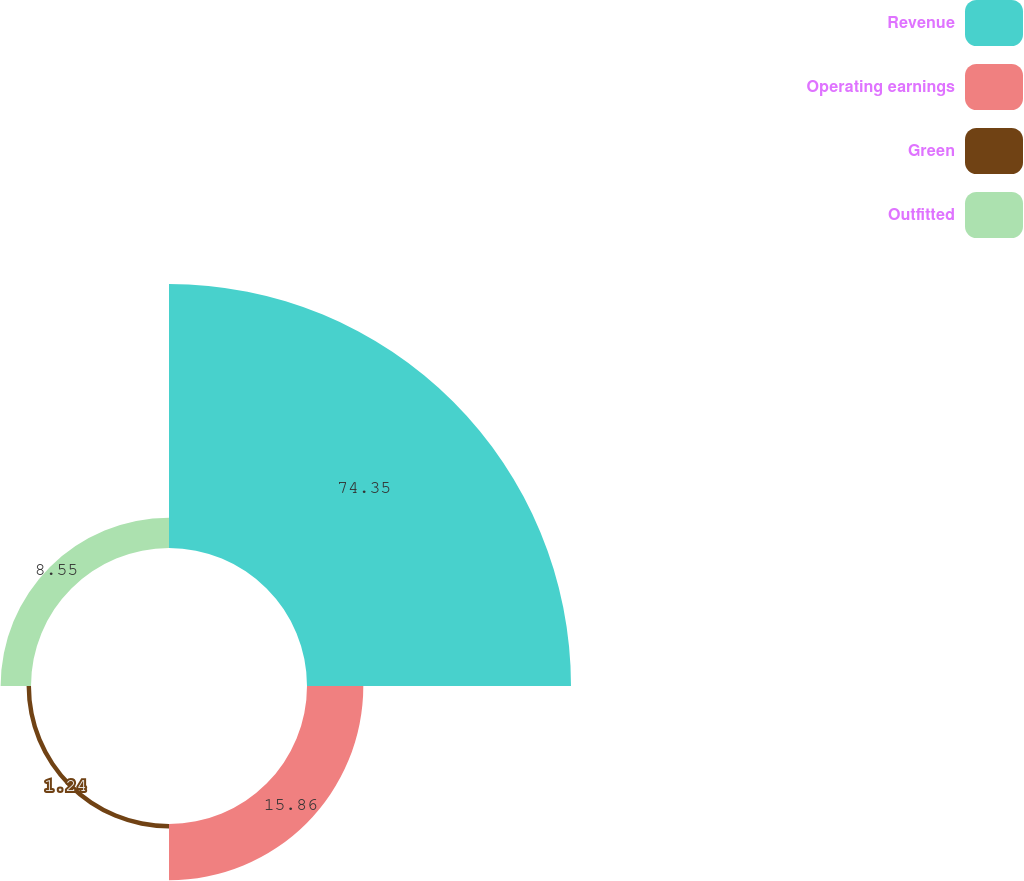<chart> <loc_0><loc_0><loc_500><loc_500><pie_chart><fcel>Revenue<fcel>Operating earnings<fcel>Green<fcel>Outfitted<nl><fcel>74.35%<fcel>15.86%<fcel>1.24%<fcel>8.55%<nl></chart> 